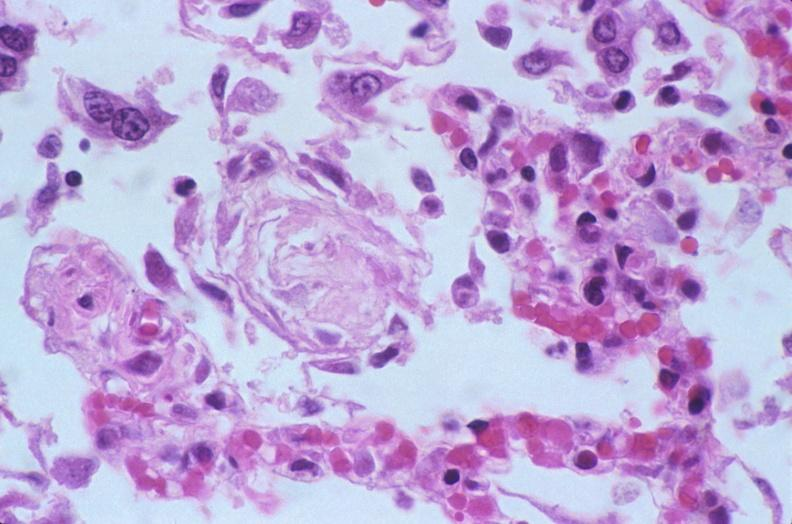what does this image show?
Answer the question using a single word or phrase. Lung 